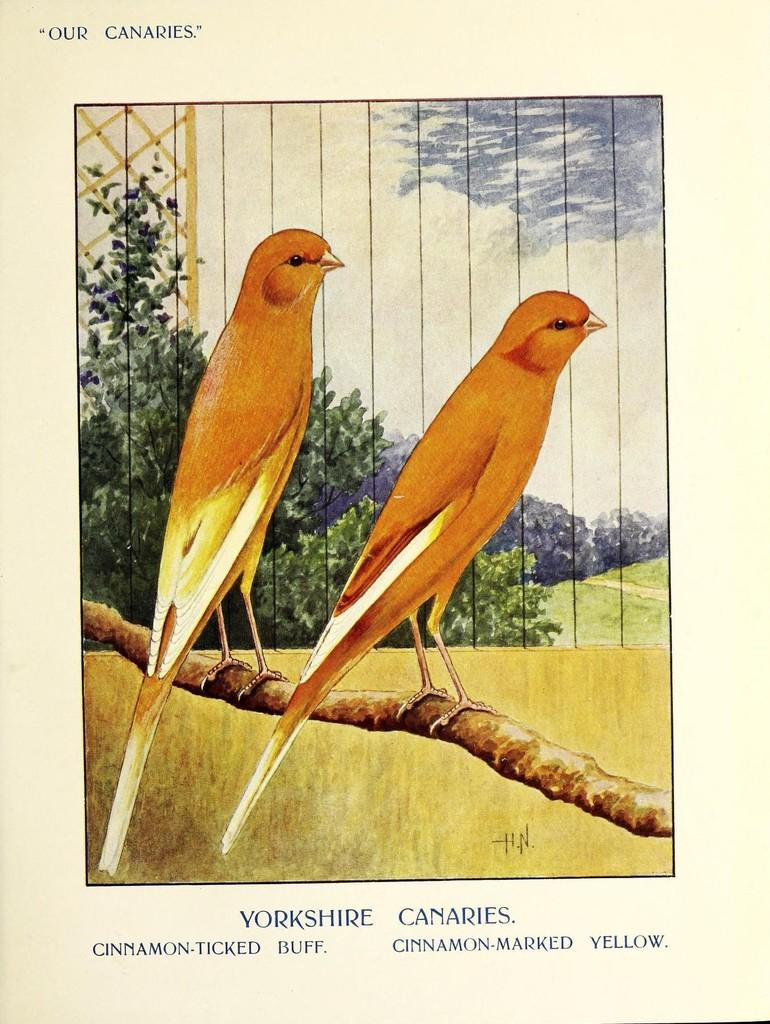What type of visual is depicted in the image? The image appears to be a poster. What can be seen in the middle of the poster? There are trees and birds in the middle of the image. Is there any text or writing on the poster? Yes, there is something written on the image. How many wires are hanging from the trees in the image? There are no wires hanging from the trees in the image. What type of quartz can be seen in the image? There is no quartz present in the image. 